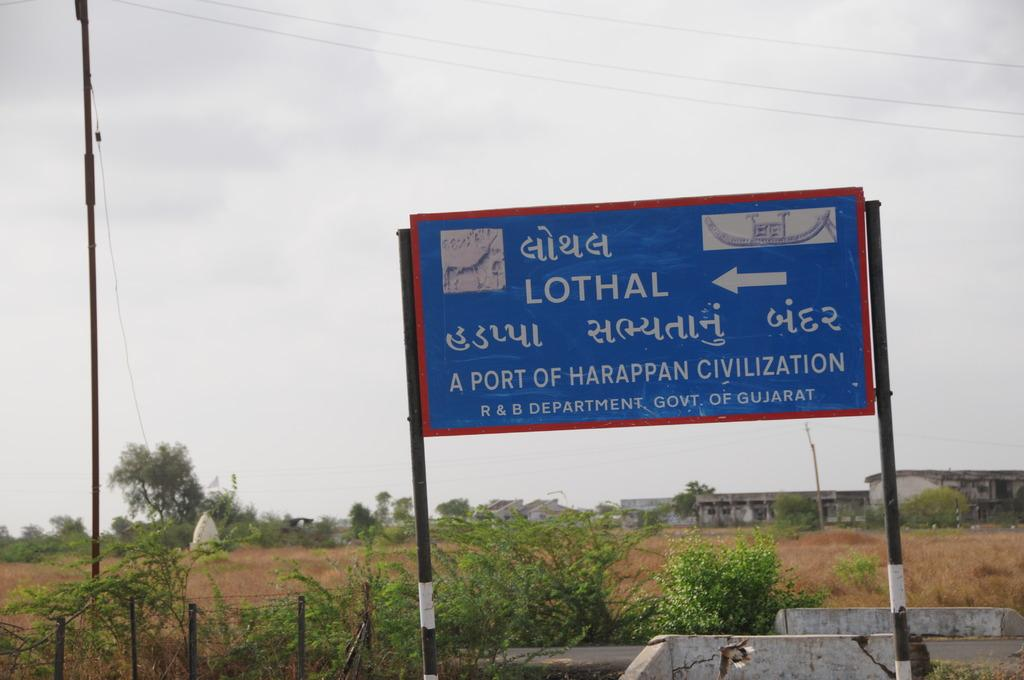<image>
Share a concise interpretation of the image provided. Grass and dirt in the background of a blue sign for Lothal. 